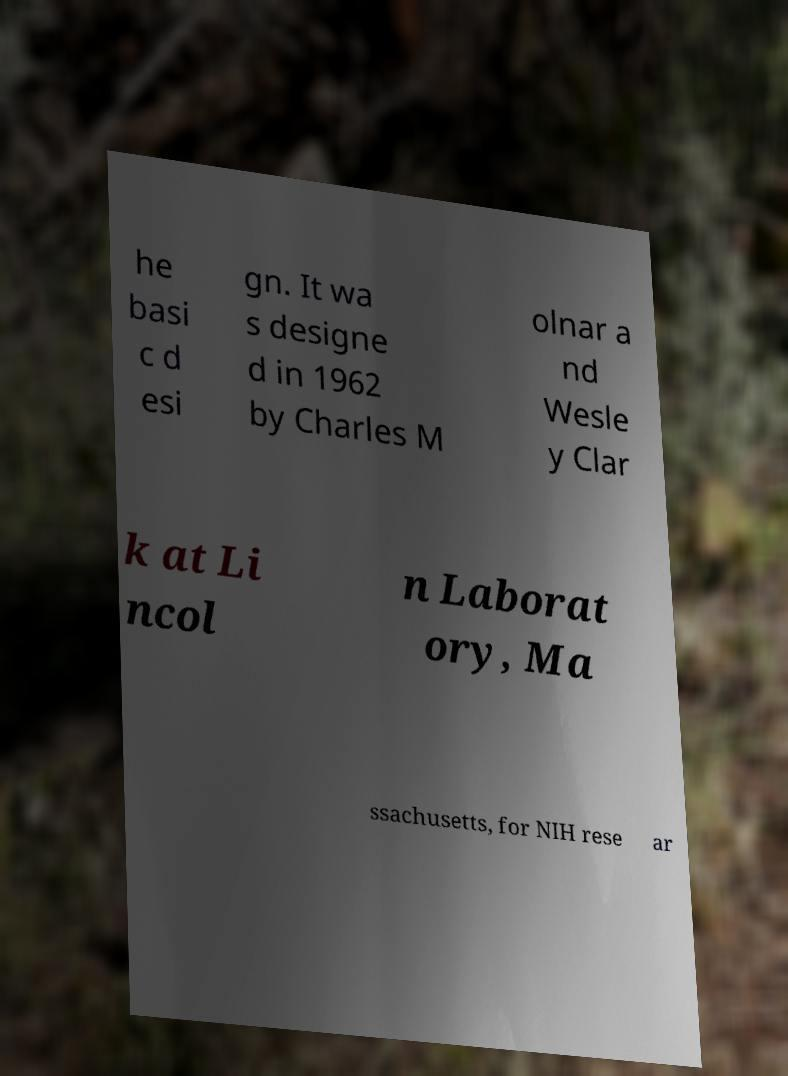Could you extract and type out the text from this image? he basi c d esi gn. It wa s designe d in 1962 by Charles M olnar a nd Wesle y Clar k at Li ncol n Laborat ory, Ma ssachusetts, for NIH rese ar 